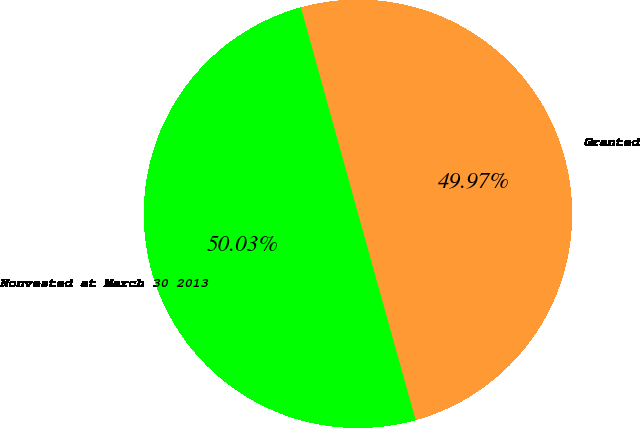<chart> <loc_0><loc_0><loc_500><loc_500><pie_chart><fcel>Granted<fcel>Nonvested at March 30 2013<nl><fcel>49.97%<fcel>50.03%<nl></chart> 